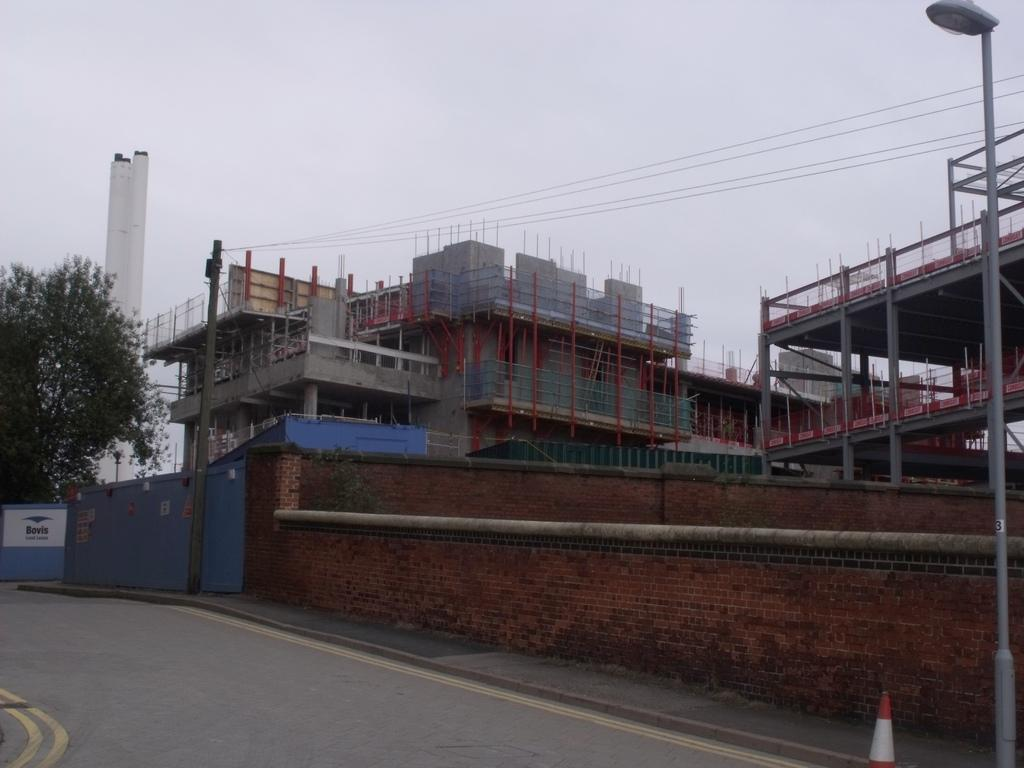What type of structures can be seen in the image? There are buildings in the image. What other man-made objects are present in the image? Electric poles, street lights, and a name board can be seen in the image. Are there any natural elements in the image? Yes, there is a tree in the image. What can be seen in the sky in the image? The sky is visible in the image. How many houses are visible in the image? The term "house" is not mentioned in the provided facts, so we cannot determine the number of houses in the image. What is the amount of road visible in the image? There is no mention of a road in the provided facts, so we cannot determine the amount of road visible in the image. 